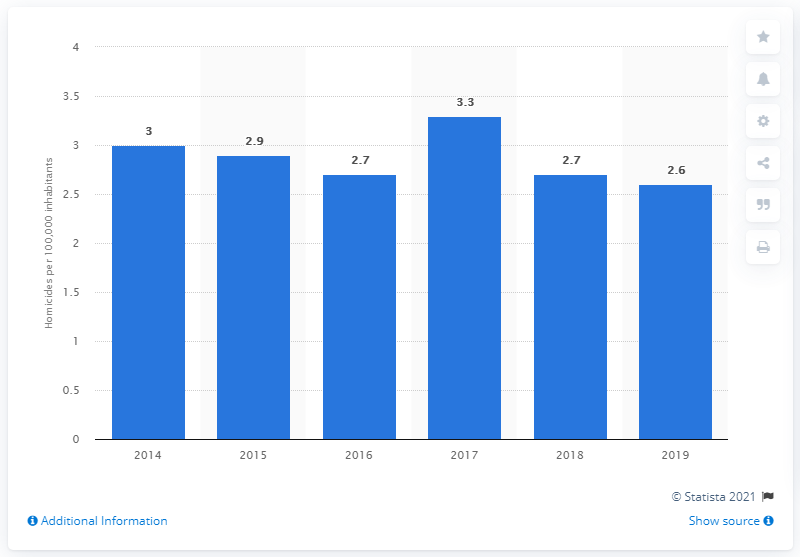Draw attention to some important aspects in this diagram. In 2019, the homicide rate in Chile was 2.6 per 100,000 inhabitants. Chile's homicide rate was 2.7 a year earlier. 